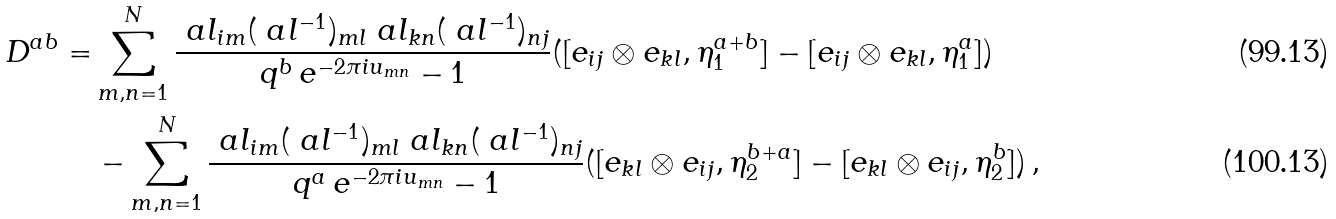<formula> <loc_0><loc_0><loc_500><loc_500>D ^ { a b } = & \sum _ { m , n = 1 } ^ { N } \frac { \ a l _ { i m } ( \ a l ^ { - 1 } ) _ { m l } \ a l _ { k n } ( \ a l ^ { - 1 } ) _ { n j } } { q ^ { b } \, e ^ { - 2 \pi i u _ { m n } } - 1 } ( [ e _ { i j } \otimes e _ { k l } , \eta ^ { a + b } _ { 1 } ] - [ e _ { i j } \otimes e _ { k l } , \eta ^ { a } _ { 1 } ] ) \\ & - \sum _ { m , n = 1 } ^ { N } \frac { \ a l _ { i m } ( \ a l ^ { - 1 } ) _ { m l } \ a l _ { k n } ( \ a l ^ { - 1 } ) _ { n j } } { q ^ { a } \, e ^ { - 2 \pi i u _ { m n } } - 1 } ( [ e _ { k l } \otimes e _ { i j } , \eta ^ { b + a } _ { 2 } ] - [ e _ { k l } \otimes e _ { i j } , \eta ^ { b } _ { 2 } ] ) \, ,</formula> 